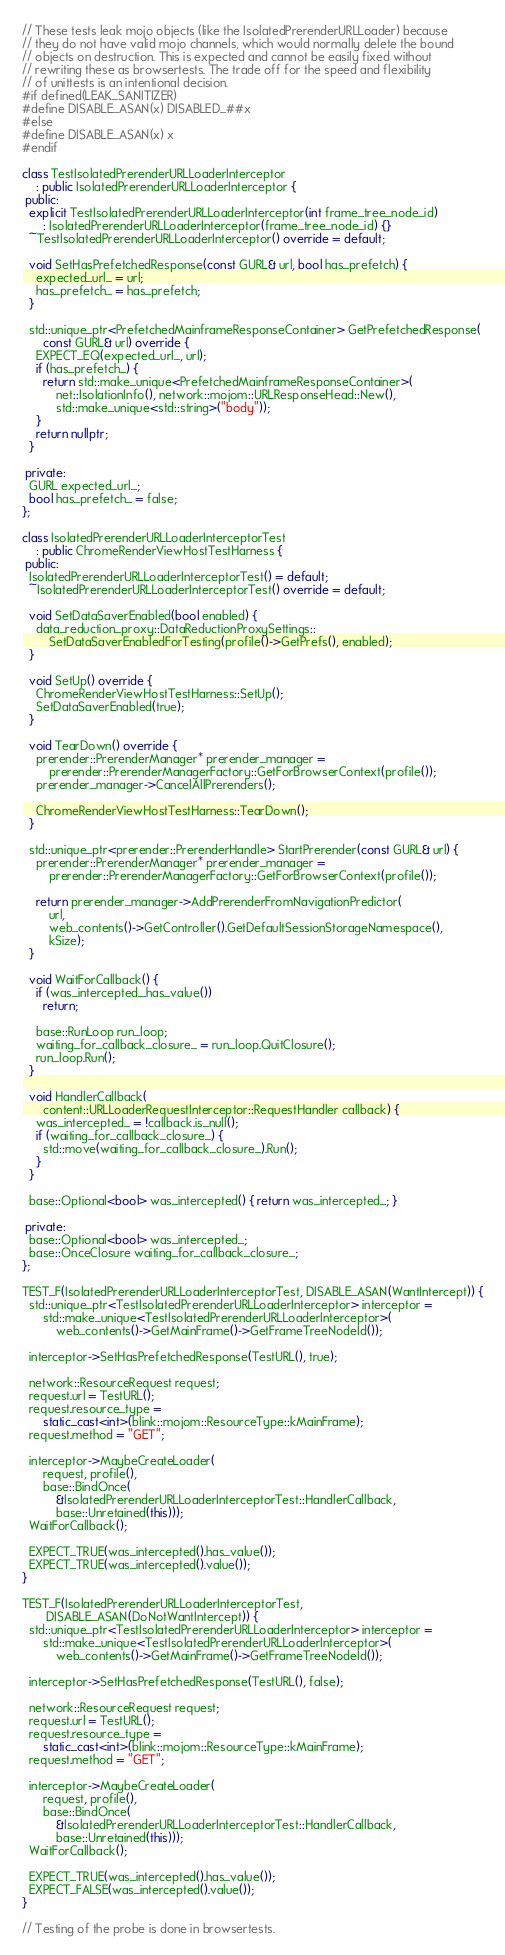Convert code to text. <code><loc_0><loc_0><loc_500><loc_500><_C++_>// These tests leak mojo objects (like the IsolatedPrerenderURLLoader) because
// they do not have valid mojo channels, which would normally delete the bound
// objects on destruction. This is expected and cannot be easily fixed without
// rewriting these as browsertests. The trade off for the speed and flexibility
// of unittests is an intentional decision.
#if defined(LEAK_SANITIZER)
#define DISABLE_ASAN(x) DISABLED_##x
#else
#define DISABLE_ASAN(x) x
#endif

class TestIsolatedPrerenderURLLoaderInterceptor
    : public IsolatedPrerenderURLLoaderInterceptor {
 public:
  explicit TestIsolatedPrerenderURLLoaderInterceptor(int frame_tree_node_id)
      : IsolatedPrerenderURLLoaderInterceptor(frame_tree_node_id) {}
  ~TestIsolatedPrerenderURLLoaderInterceptor() override = default;

  void SetHasPrefetchedResponse(const GURL& url, bool has_prefetch) {
    expected_url_ = url;
    has_prefetch_ = has_prefetch;
  }

  std::unique_ptr<PrefetchedMainframeResponseContainer> GetPrefetchedResponse(
      const GURL& url) override {
    EXPECT_EQ(expected_url_, url);
    if (has_prefetch_) {
      return std::make_unique<PrefetchedMainframeResponseContainer>(
          net::IsolationInfo(), network::mojom::URLResponseHead::New(),
          std::make_unique<std::string>("body"));
    }
    return nullptr;
  }

 private:
  GURL expected_url_;
  bool has_prefetch_ = false;
};

class IsolatedPrerenderURLLoaderInterceptorTest
    : public ChromeRenderViewHostTestHarness {
 public:
  IsolatedPrerenderURLLoaderInterceptorTest() = default;
  ~IsolatedPrerenderURLLoaderInterceptorTest() override = default;

  void SetDataSaverEnabled(bool enabled) {
    data_reduction_proxy::DataReductionProxySettings::
        SetDataSaverEnabledForTesting(profile()->GetPrefs(), enabled);
  }

  void SetUp() override {
    ChromeRenderViewHostTestHarness::SetUp();
    SetDataSaverEnabled(true);
  }

  void TearDown() override {
    prerender::PrerenderManager* prerender_manager =
        prerender::PrerenderManagerFactory::GetForBrowserContext(profile());
    prerender_manager->CancelAllPrerenders();

    ChromeRenderViewHostTestHarness::TearDown();
  }

  std::unique_ptr<prerender::PrerenderHandle> StartPrerender(const GURL& url) {
    prerender::PrerenderManager* prerender_manager =
        prerender::PrerenderManagerFactory::GetForBrowserContext(profile());

    return prerender_manager->AddPrerenderFromNavigationPredictor(
        url,
        web_contents()->GetController().GetDefaultSessionStorageNamespace(),
        kSize);
  }

  void WaitForCallback() {
    if (was_intercepted_.has_value())
      return;

    base::RunLoop run_loop;
    waiting_for_callback_closure_ = run_loop.QuitClosure();
    run_loop.Run();
  }

  void HandlerCallback(
      content::URLLoaderRequestInterceptor::RequestHandler callback) {
    was_intercepted_ = !callback.is_null();
    if (waiting_for_callback_closure_) {
      std::move(waiting_for_callback_closure_).Run();
    }
  }

  base::Optional<bool> was_intercepted() { return was_intercepted_; }

 private:
  base::Optional<bool> was_intercepted_;
  base::OnceClosure waiting_for_callback_closure_;
};

TEST_F(IsolatedPrerenderURLLoaderInterceptorTest, DISABLE_ASAN(WantIntercept)) {
  std::unique_ptr<TestIsolatedPrerenderURLLoaderInterceptor> interceptor =
      std::make_unique<TestIsolatedPrerenderURLLoaderInterceptor>(
          web_contents()->GetMainFrame()->GetFrameTreeNodeId());

  interceptor->SetHasPrefetchedResponse(TestURL(), true);

  network::ResourceRequest request;
  request.url = TestURL();
  request.resource_type =
      static_cast<int>(blink::mojom::ResourceType::kMainFrame);
  request.method = "GET";

  interceptor->MaybeCreateLoader(
      request, profile(),
      base::BindOnce(
          &IsolatedPrerenderURLLoaderInterceptorTest::HandlerCallback,
          base::Unretained(this)));
  WaitForCallback();

  EXPECT_TRUE(was_intercepted().has_value());
  EXPECT_TRUE(was_intercepted().value());
}

TEST_F(IsolatedPrerenderURLLoaderInterceptorTest,
       DISABLE_ASAN(DoNotWantIntercept)) {
  std::unique_ptr<TestIsolatedPrerenderURLLoaderInterceptor> interceptor =
      std::make_unique<TestIsolatedPrerenderURLLoaderInterceptor>(
          web_contents()->GetMainFrame()->GetFrameTreeNodeId());

  interceptor->SetHasPrefetchedResponse(TestURL(), false);

  network::ResourceRequest request;
  request.url = TestURL();
  request.resource_type =
      static_cast<int>(blink::mojom::ResourceType::kMainFrame);
  request.method = "GET";

  interceptor->MaybeCreateLoader(
      request, profile(),
      base::BindOnce(
          &IsolatedPrerenderURLLoaderInterceptorTest::HandlerCallback,
          base::Unretained(this)));
  WaitForCallback();

  EXPECT_TRUE(was_intercepted().has_value());
  EXPECT_FALSE(was_intercepted().value());
}

// Testing of the probe is done in browsertests.
</code> 